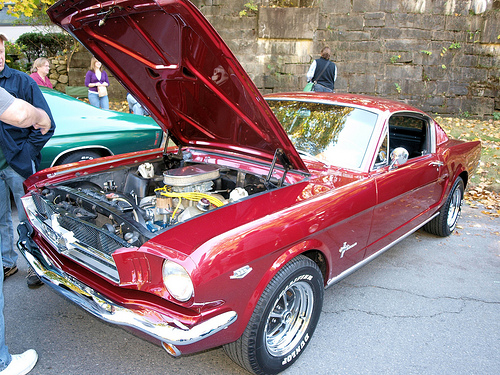<image>
Is the tire on the car? Yes. Looking at the image, I can see the tire is positioned on top of the car, with the car providing support. 